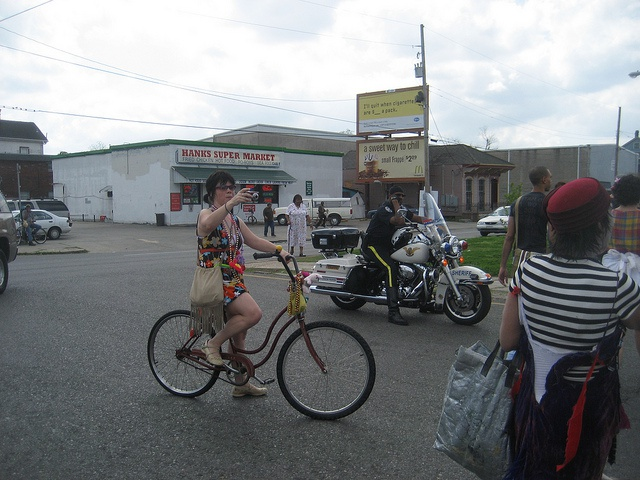Describe the objects in this image and their specific colors. I can see people in lightgray, black, gray, maroon, and darkgray tones, motorcycle in lightgray, black, gray, and darkgray tones, bicycle in lightgray, gray, black, and darkgray tones, handbag in lightgray, gray, black, and purple tones, and people in lightgray, gray, black, and maroon tones in this image. 